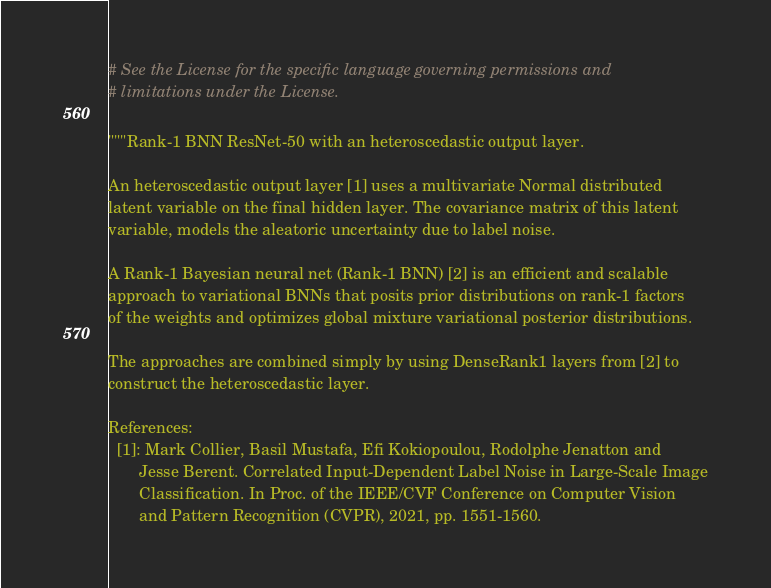<code> <loc_0><loc_0><loc_500><loc_500><_Python_># See the License for the specific language governing permissions and
# limitations under the License.

"""Rank-1 BNN ResNet-50 with an heteroscedastic output layer.

An heteroscedastic output layer [1] uses a multivariate Normal distributed
latent variable on the final hidden layer. The covariance matrix of this latent
variable, models the aleatoric uncertainty due to label noise.

A Rank-1 Bayesian neural net (Rank-1 BNN) [2] is an efficient and scalable
approach to variational BNNs that posits prior distributions on rank-1 factors
of the weights and optimizes global mixture variational posterior distributions.

The approaches are combined simply by using DenseRank1 layers from [2] to
construct the heteroscedastic layer.

References:
  [1]: Mark Collier, Basil Mustafa, Efi Kokiopoulou, Rodolphe Jenatton and
       Jesse Berent. Correlated Input-Dependent Label Noise in Large-Scale Image
       Classification. In Proc. of the IEEE/CVF Conference on Computer Vision
       and Pattern Recognition (CVPR), 2021, pp. 1551-1560.</code> 